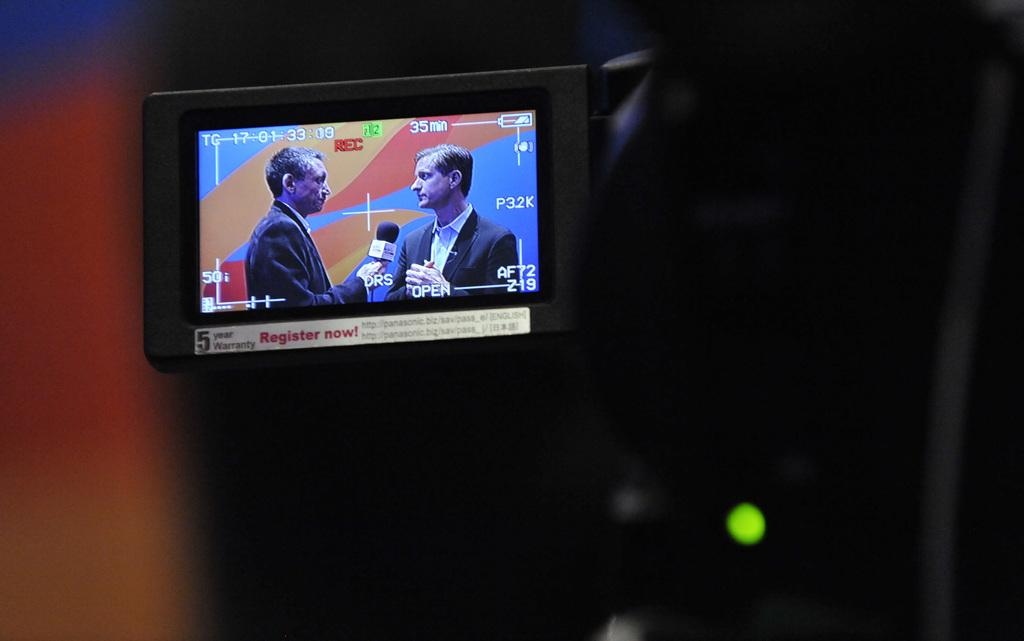<image>
Present a compact description of the photo's key features. Two men are on a television screen, with a microphone between them and the message to register now below them. 